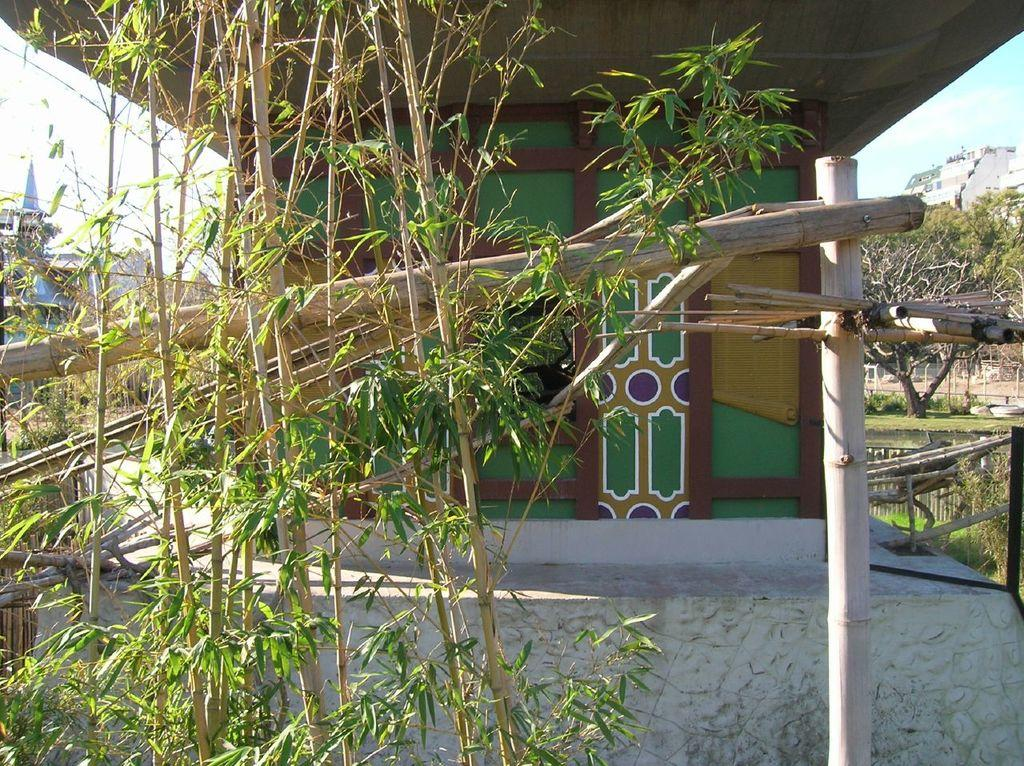What is located in the foreground of the image? There are plants and wooden sticks in the foreground of the image. What can be seen in the background of the image? There are buildings in the background of the image. What type of pail is being used to collect water from the plants in the image? There is no pail present in the image; it only features plants and wooden sticks in the foreground. What religious symbols can be seen in the image? There are no religious symbols present in the image. 